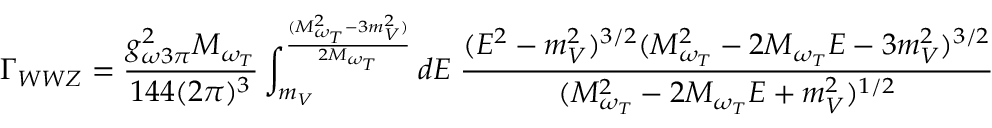Convert formula to latex. <formula><loc_0><loc_0><loc_500><loc_500>\Gamma _ { W W Z } = \frac { g _ { \omega 3 \pi } ^ { 2 } M _ { \omega _ { T } } } { 1 4 4 ( 2 \pi ) ^ { 3 } } \int _ { m _ { V } } ^ { \frac { ( M _ { \omega _ { T } } ^ { 2 } - 3 m _ { V } ^ { 2 } ) } { 2 M _ { \omega _ { T } } } } d E \, \frac { ( E ^ { 2 } - m _ { V } ^ { 2 } ) ^ { 3 / 2 } ( M _ { \omega _ { T } } ^ { 2 } - 2 M _ { \omega _ { T } } E - 3 m _ { V } ^ { 2 } ) ^ { 3 / 2 } } { ( M _ { \omega _ { T } } ^ { 2 } - 2 M _ { \omega _ { T } } E + m _ { V } ^ { 2 } ) ^ { 1 / 2 } }</formula> 